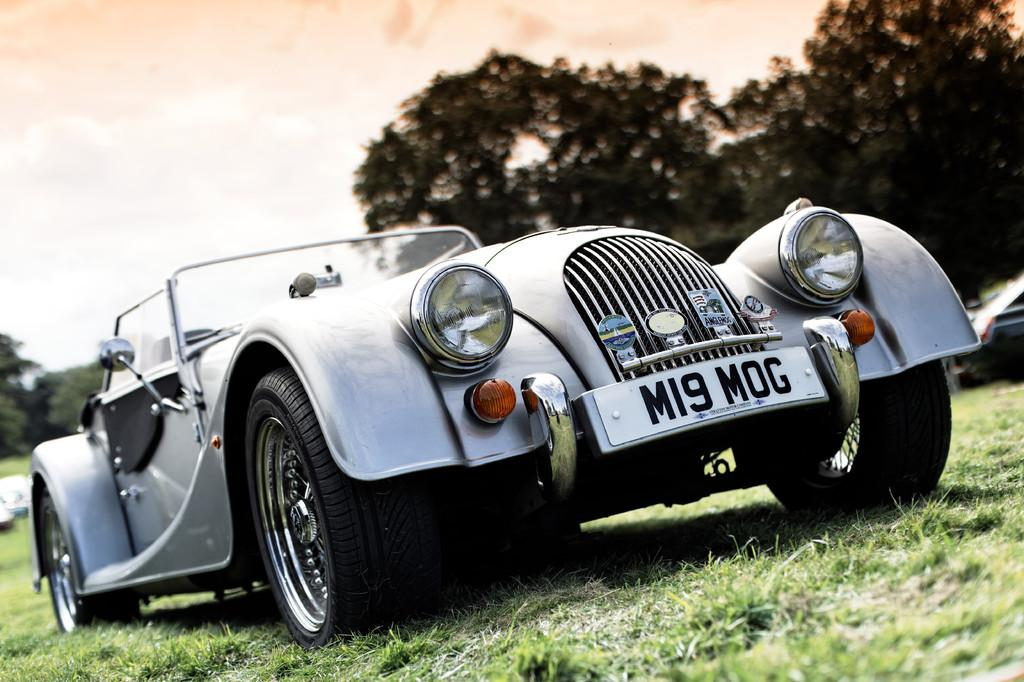What is the main subject of the image? There is a car in the image. What can be seen in the background of the image? Trees are visible in the image. How many cows are grazing near the harbor in the image? There is no harbor or cows present in the image; it features a car and trees. 